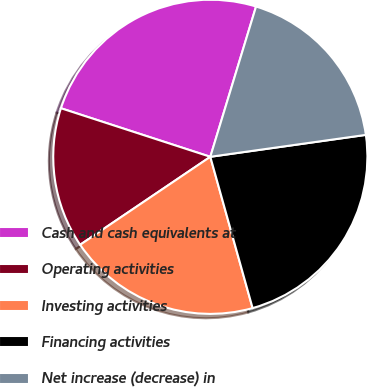Convert chart. <chart><loc_0><loc_0><loc_500><loc_500><pie_chart><fcel>Cash and cash equivalents at<fcel>Operating activities<fcel>Investing activities<fcel>Financing activities<fcel>Net increase (decrease) in<nl><fcel>24.7%<fcel>14.46%<fcel>19.88%<fcel>22.89%<fcel>18.07%<nl></chart> 